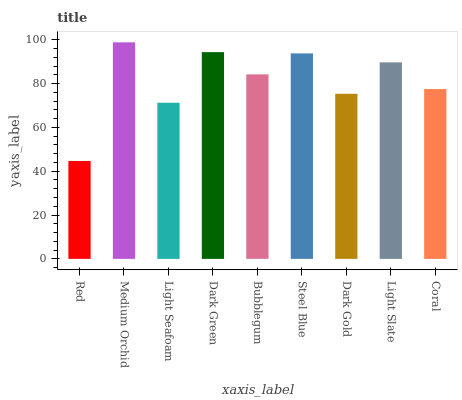Is Light Seafoam the minimum?
Answer yes or no. No. Is Light Seafoam the maximum?
Answer yes or no. No. Is Medium Orchid greater than Light Seafoam?
Answer yes or no. Yes. Is Light Seafoam less than Medium Orchid?
Answer yes or no. Yes. Is Light Seafoam greater than Medium Orchid?
Answer yes or no. No. Is Medium Orchid less than Light Seafoam?
Answer yes or no. No. Is Bubblegum the high median?
Answer yes or no. Yes. Is Bubblegum the low median?
Answer yes or no. Yes. Is Steel Blue the high median?
Answer yes or no. No. Is Coral the low median?
Answer yes or no. No. 